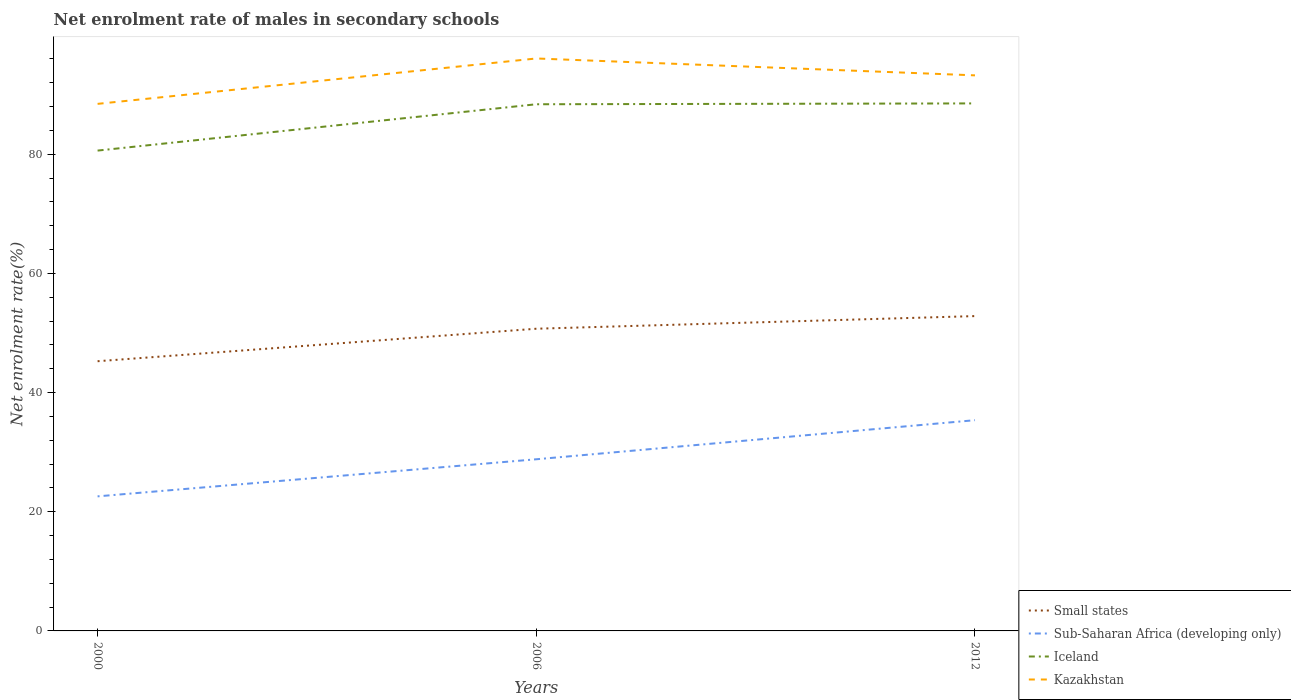Does the line corresponding to Small states intersect with the line corresponding to Sub-Saharan Africa (developing only)?
Your answer should be very brief. No. Is the number of lines equal to the number of legend labels?
Keep it short and to the point. Yes. Across all years, what is the maximum net enrolment rate of males in secondary schools in Iceland?
Keep it short and to the point. 80.61. In which year was the net enrolment rate of males in secondary schools in Iceland maximum?
Make the answer very short. 2000. What is the total net enrolment rate of males in secondary schools in Kazakhstan in the graph?
Provide a short and direct response. -4.79. What is the difference between the highest and the second highest net enrolment rate of males in secondary schools in Kazakhstan?
Keep it short and to the point. 7.62. Is the net enrolment rate of males in secondary schools in Kazakhstan strictly greater than the net enrolment rate of males in secondary schools in Iceland over the years?
Your answer should be compact. No. Are the values on the major ticks of Y-axis written in scientific E-notation?
Provide a succinct answer. No. Does the graph contain any zero values?
Give a very brief answer. No. Does the graph contain grids?
Offer a very short reply. No. How many legend labels are there?
Offer a terse response. 4. What is the title of the graph?
Provide a short and direct response. Net enrolment rate of males in secondary schools. Does "Euro area" appear as one of the legend labels in the graph?
Provide a succinct answer. No. What is the label or title of the X-axis?
Provide a short and direct response. Years. What is the label or title of the Y-axis?
Your response must be concise. Net enrolment rate(%). What is the Net enrolment rate(%) of Small states in 2000?
Make the answer very short. 45.26. What is the Net enrolment rate(%) of Sub-Saharan Africa (developing only) in 2000?
Your response must be concise. 22.58. What is the Net enrolment rate(%) in Iceland in 2000?
Your response must be concise. 80.61. What is the Net enrolment rate(%) of Kazakhstan in 2000?
Give a very brief answer. 88.45. What is the Net enrolment rate(%) of Small states in 2006?
Offer a very short reply. 50.71. What is the Net enrolment rate(%) in Sub-Saharan Africa (developing only) in 2006?
Make the answer very short. 28.81. What is the Net enrolment rate(%) of Iceland in 2006?
Ensure brevity in your answer.  88.39. What is the Net enrolment rate(%) of Kazakhstan in 2006?
Give a very brief answer. 96.07. What is the Net enrolment rate(%) in Small states in 2012?
Your answer should be very brief. 52.84. What is the Net enrolment rate(%) in Sub-Saharan Africa (developing only) in 2012?
Provide a succinct answer. 35.37. What is the Net enrolment rate(%) of Iceland in 2012?
Your answer should be compact. 88.53. What is the Net enrolment rate(%) of Kazakhstan in 2012?
Your response must be concise. 93.24. Across all years, what is the maximum Net enrolment rate(%) in Small states?
Offer a very short reply. 52.84. Across all years, what is the maximum Net enrolment rate(%) in Sub-Saharan Africa (developing only)?
Offer a very short reply. 35.37. Across all years, what is the maximum Net enrolment rate(%) of Iceland?
Offer a very short reply. 88.53. Across all years, what is the maximum Net enrolment rate(%) in Kazakhstan?
Make the answer very short. 96.07. Across all years, what is the minimum Net enrolment rate(%) of Small states?
Provide a short and direct response. 45.26. Across all years, what is the minimum Net enrolment rate(%) of Sub-Saharan Africa (developing only)?
Make the answer very short. 22.58. Across all years, what is the minimum Net enrolment rate(%) of Iceland?
Your response must be concise. 80.61. Across all years, what is the minimum Net enrolment rate(%) in Kazakhstan?
Ensure brevity in your answer.  88.45. What is the total Net enrolment rate(%) of Small states in the graph?
Your answer should be compact. 148.81. What is the total Net enrolment rate(%) in Sub-Saharan Africa (developing only) in the graph?
Ensure brevity in your answer.  86.75. What is the total Net enrolment rate(%) of Iceland in the graph?
Your answer should be compact. 257.52. What is the total Net enrolment rate(%) in Kazakhstan in the graph?
Your response must be concise. 277.75. What is the difference between the Net enrolment rate(%) in Small states in 2000 and that in 2006?
Your answer should be compact. -5.45. What is the difference between the Net enrolment rate(%) in Sub-Saharan Africa (developing only) in 2000 and that in 2006?
Your response must be concise. -6.22. What is the difference between the Net enrolment rate(%) of Iceland in 2000 and that in 2006?
Keep it short and to the point. -7.78. What is the difference between the Net enrolment rate(%) in Kazakhstan in 2000 and that in 2006?
Offer a very short reply. -7.62. What is the difference between the Net enrolment rate(%) of Small states in 2000 and that in 2012?
Offer a terse response. -7.57. What is the difference between the Net enrolment rate(%) in Sub-Saharan Africa (developing only) in 2000 and that in 2012?
Give a very brief answer. -12.78. What is the difference between the Net enrolment rate(%) of Iceland in 2000 and that in 2012?
Give a very brief answer. -7.92. What is the difference between the Net enrolment rate(%) of Kazakhstan in 2000 and that in 2012?
Make the answer very short. -4.79. What is the difference between the Net enrolment rate(%) of Small states in 2006 and that in 2012?
Your answer should be compact. -2.12. What is the difference between the Net enrolment rate(%) of Sub-Saharan Africa (developing only) in 2006 and that in 2012?
Ensure brevity in your answer.  -6.56. What is the difference between the Net enrolment rate(%) in Iceland in 2006 and that in 2012?
Offer a very short reply. -0.14. What is the difference between the Net enrolment rate(%) in Kazakhstan in 2006 and that in 2012?
Make the answer very short. 2.83. What is the difference between the Net enrolment rate(%) of Small states in 2000 and the Net enrolment rate(%) of Sub-Saharan Africa (developing only) in 2006?
Give a very brief answer. 16.46. What is the difference between the Net enrolment rate(%) in Small states in 2000 and the Net enrolment rate(%) in Iceland in 2006?
Ensure brevity in your answer.  -43.12. What is the difference between the Net enrolment rate(%) of Small states in 2000 and the Net enrolment rate(%) of Kazakhstan in 2006?
Offer a very short reply. -50.81. What is the difference between the Net enrolment rate(%) of Sub-Saharan Africa (developing only) in 2000 and the Net enrolment rate(%) of Iceland in 2006?
Offer a terse response. -65.8. What is the difference between the Net enrolment rate(%) in Sub-Saharan Africa (developing only) in 2000 and the Net enrolment rate(%) in Kazakhstan in 2006?
Ensure brevity in your answer.  -73.49. What is the difference between the Net enrolment rate(%) in Iceland in 2000 and the Net enrolment rate(%) in Kazakhstan in 2006?
Your response must be concise. -15.46. What is the difference between the Net enrolment rate(%) of Small states in 2000 and the Net enrolment rate(%) of Sub-Saharan Africa (developing only) in 2012?
Give a very brief answer. 9.9. What is the difference between the Net enrolment rate(%) of Small states in 2000 and the Net enrolment rate(%) of Iceland in 2012?
Provide a short and direct response. -43.27. What is the difference between the Net enrolment rate(%) of Small states in 2000 and the Net enrolment rate(%) of Kazakhstan in 2012?
Make the answer very short. -47.97. What is the difference between the Net enrolment rate(%) in Sub-Saharan Africa (developing only) in 2000 and the Net enrolment rate(%) in Iceland in 2012?
Give a very brief answer. -65.94. What is the difference between the Net enrolment rate(%) of Sub-Saharan Africa (developing only) in 2000 and the Net enrolment rate(%) of Kazakhstan in 2012?
Keep it short and to the point. -70.65. What is the difference between the Net enrolment rate(%) of Iceland in 2000 and the Net enrolment rate(%) of Kazakhstan in 2012?
Offer a terse response. -12.62. What is the difference between the Net enrolment rate(%) of Small states in 2006 and the Net enrolment rate(%) of Sub-Saharan Africa (developing only) in 2012?
Your response must be concise. 15.35. What is the difference between the Net enrolment rate(%) in Small states in 2006 and the Net enrolment rate(%) in Iceland in 2012?
Keep it short and to the point. -37.81. What is the difference between the Net enrolment rate(%) of Small states in 2006 and the Net enrolment rate(%) of Kazakhstan in 2012?
Offer a very short reply. -42.52. What is the difference between the Net enrolment rate(%) in Sub-Saharan Africa (developing only) in 2006 and the Net enrolment rate(%) in Iceland in 2012?
Provide a short and direct response. -59.72. What is the difference between the Net enrolment rate(%) of Sub-Saharan Africa (developing only) in 2006 and the Net enrolment rate(%) of Kazakhstan in 2012?
Your answer should be compact. -64.43. What is the difference between the Net enrolment rate(%) in Iceland in 2006 and the Net enrolment rate(%) in Kazakhstan in 2012?
Ensure brevity in your answer.  -4.85. What is the average Net enrolment rate(%) of Small states per year?
Your response must be concise. 49.6. What is the average Net enrolment rate(%) of Sub-Saharan Africa (developing only) per year?
Your answer should be very brief. 28.92. What is the average Net enrolment rate(%) in Iceland per year?
Offer a terse response. 85.84. What is the average Net enrolment rate(%) of Kazakhstan per year?
Offer a very short reply. 92.58. In the year 2000, what is the difference between the Net enrolment rate(%) of Small states and Net enrolment rate(%) of Sub-Saharan Africa (developing only)?
Your answer should be very brief. 22.68. In the year 2000, what is the difference between the Net enrolment rate(%) in Small states and Net enrolment rate(%) in Iceland?
Keep it short and to the point. -35.35. In the year 2000, what is the difference between the Net enrolment rate(%) of Small states and Net enrolment rate(%) of Kazakhstan?
Offer a terse response. -43.19. In the year 2000, what is the difference between the Net enrolment rate(%) in Sub-Saharan Africa (developing only) and Net enrolment rate(%) in Iceland?
Make the answer very short. -58.03. In the year 2000, what is the difference between the Net enrolment rate(%) of Sub-Saharan Africa (developing only) and Net enrolment rate(%) of Kazakhstan?
Ensure brevity in your answer.  -65.87. In the year 2000, what is the difference between the Net enrolment rate(%) in Iceland and Net enrolment rate(%) in Kazakhstan?
Your answer should be very brief. -7.84. In the year 2006, what is the difference between the Net enrolment rate(%) of Small states and Net enrolment rate(%) of Sub-Saharan Africa (developing only)?
Offer a terse response. 21.91. In the year 2006, what is the difference between the Net enrolment rate(%) of Small states and Net enrolment rate(%) of Iceland?
Give a very brief answer. -37.67. In the year 2006, what is the difference between the Net enrolment rate(%) in Small states and Net enrolment rate(%) in Kazakhstan?
Make the answer very short. -45.35. In the year 2006, what is the difference between the Net enrolment rate(%) in Sub-Saharan Africa (developing only) and Net enrolment rate(%) in Iceland?
Your response must be concise. -59.58. In the year 2006, what is the difference between the Net enrolment rate(%) of Sub-Saharan Africa (developing only) and Net enrolment rate(%) of Kazakhstan?
Keep it short and to the point. -67.26. In the year 2006, what is the difference between the Net enrolment rate(%) of Iceland and Net enrolment rate(%) of Kazakhstan?
Keep it short and to the point. -7.68. In the year 2012, what is the difference between the Net enrolment rate(%) in Small states and Net enrolment rate(%) in Sub-Saharan Africa (developing only)?
Offer a very short reply. 17.47. In the year 2012, what is the difference between the Net enrolment rate(%) in Small states and Net enrolment rate(%) in Iceland?
Offer a terse response. -35.69. In the year 2012, what is the difference between the Net enrolment rate(%) of Small states and Net enrolment rate(%) of Kazakhstan?
Your response must be concise. -40.4. In the year 2012, what is the difference between the Net enrolment rate(%) of Sub-Saharan Africa (developing only) and Net enrolment rate(%) of Iceland?
Provide a short and direct response. -53.16. In the year 2012, what is the difference between the Net enrolment rate(%) of Sub-Saharan Africa (developing only) and Net enrolment rate(%) of Kazakhstan?
Offer a very short reply. -57.87. In the year 2012, what is the difference between the Net enrolment rate(%) of Iceland and Net enrolment rate(%) of Kazakhstan?
Make the answer very short. -4.71. What is the ratio of the Net enrolment rate(%) of Small states in 2000 to that in 2006?
Make the answer very short. 0.89. What is the ratio of the Net enrolment rate(%) of Sub-Saharan Africa (developing only) in 2000 to that in 2006?
Keep it short and to the point. 0.78. What is the ratio of the Net enrolment rate(%) of Iceland in 2000 to that in 2006?
Your response must be concise. 0.91. What is the ratio of the Net enrolment rate(%) in Kazakhstan in 2000 to that in 2006?
Keep it short and to the point. 0.92. What is the ratio of the Net enrolment rate(%) of Small states in 2000 to that in 2012?
Provide a succinct answer. 0.86. What is the ratio of the Net enrolment rate(%) of Sub-Saharan Africa (developing only) in 2000 to that in 2012?
Offer a terse response. 0.64. What is the ratio of the Net enrolment rate(%) in Iceland in 2000 to that in 2012?
Offer a very short reply. 0.91. What is the ratio of the Net enrolment rate(%) of Kazakhstan in 2000 to that in 2012?
Your answer should be very brief. 0.95. What is the ratio of the Net enrolment rate(%) of Small states in 2006 to that in 2012?
Offer a very short reply. 0.96. What is the ratio of the Net enrolment rate(%) of Sub-Saharan Africa (developing only) in 2006 to that in 2012?
Offer a terse response. 0.81. What is the ratio of the Net enrolment rate(%) of Kazakhstan in 2006 to that in 2012?
Keep it short and to the point. 1.03. What is the difference between the highest and the second highest Net enrolment rate(%) in Small states?
Your response must be concise. 2.12. What is the difference between the highest and the second highest Net enrolment rate(%) in Sub-Saharan Africa (developing only)?
Your answer should be compact. 6.56. What is the difference between the highest and the second highest Net enrolment rate(%) in Iceland?
Provide a short and direct response. 0.14. What is the difference between the highest and the second highest Net enrolment rate(%) in Kazakhstan?
Make the answer very short. 2.83. What is the difference between the highest and the lowest Net enrolment rate(%) of Small states?
Offer a very short reply. 7.57. What is the difference between the highest and the lowest Net enrolment rate(%) in Sub-Saharan Africa (developing only)?
Make the answer very short. 12.78. What is the difference between the highest and the lowest Net enrolment rate(%) of Iceland?
Ensure brevity in your answer.  7.92. What is the difference between the highest and the lowest Net enrolment rate(%) in Kazakhstan?
Your answer should be compact. 7.62. 